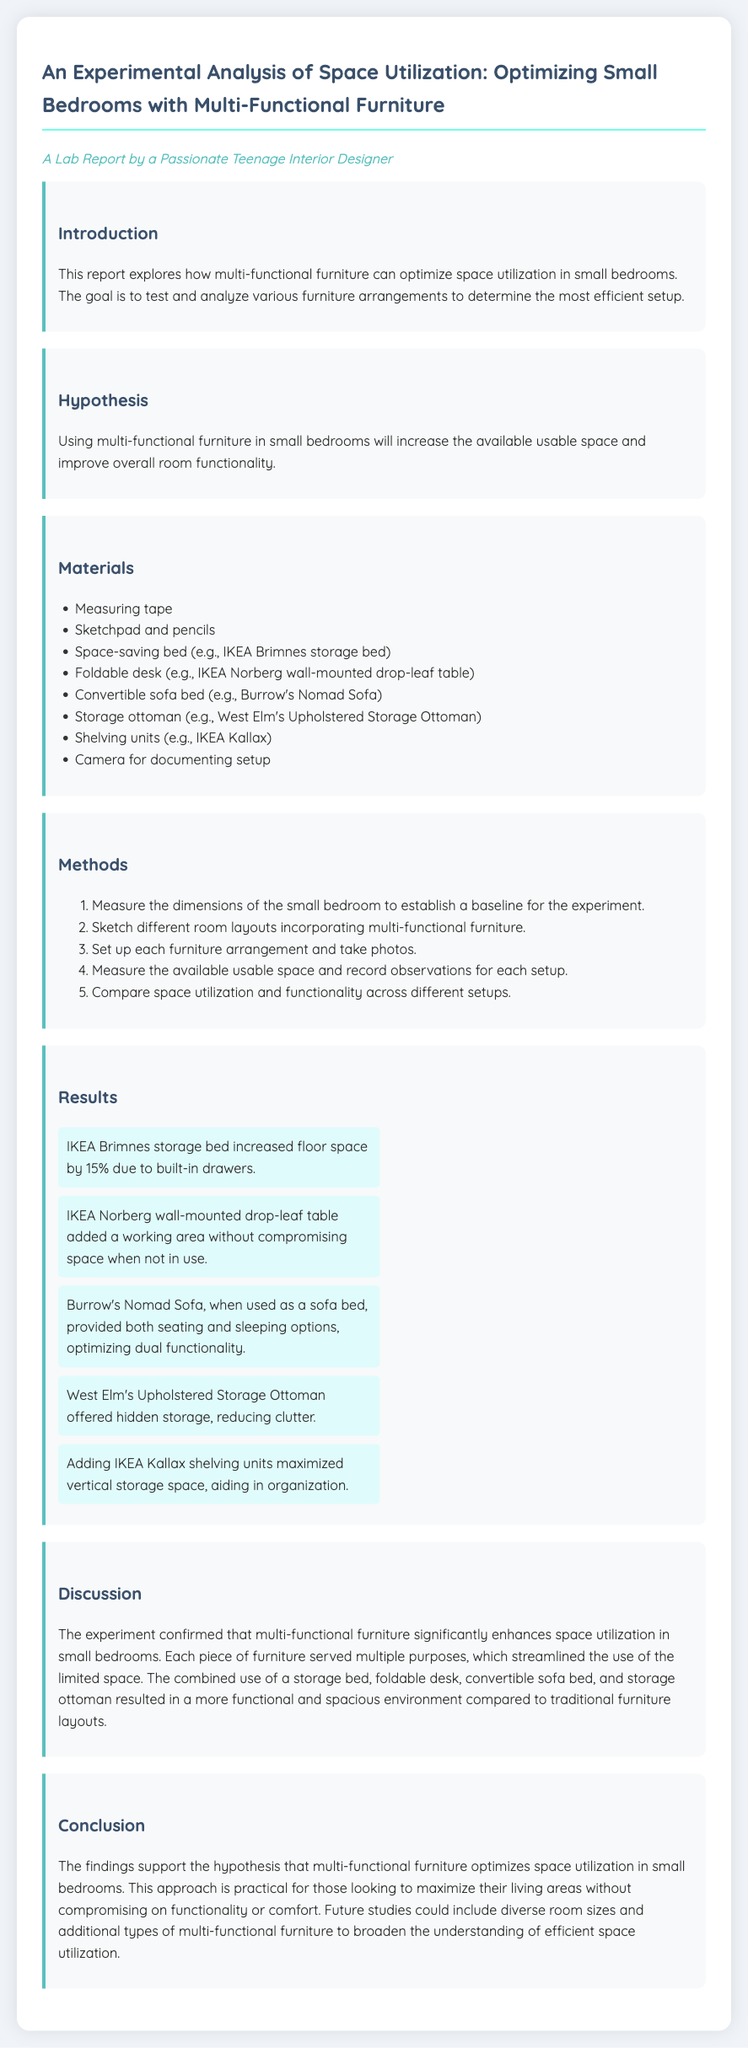what is the title of the lab report? The title of the lab report is specifically mentioned at the beginning of the document.
Answer: An Experimental Analysis of Space Utilization: Optimizing Small Bedrooms with Multi-Functional Furniture what is the hypothesis stated in the report? The hypothesis can be found in the section titled "Hypothesis."
Answer: Using multi-functional furniture in small bedrooms will increase the available usable space and improve overall room functionality how many materials are listed in the report? The number of materials can be counted from the "Materials" section of the document.
Answer: Eight which multi-functional furniture provided a working area without compromising space? This information is provided in the "Results" section where specific furniture functions are described.
Answer: IKEA Norberg wall-mounted drop-leaf table what percentage of floor space did the IKEA Brimnes storage bed increase? The percentage mentioned in the "Results" section indicates the impact on floor space by this furniture.
Answer: 15% what is one benefit of using a storage ottoman according to the results? The benefit is directly stated in the "Results" section discussing the advantages of the storage ottoman.
Answer: Hidden storage what conclusion is drawn about multi-functional furniture? The conclusion summarizes the overall findings and implications of the experiment.
Answer: Multi-functional furniture optimizes space utilization in small bedrooms what could future studies include to broaden the understanding of efficient space utilization? This is mentioned in the "Conclusion" section regarding the suggestions for further research.
Answer: Diverse room sizes and additional types of multi-functional furniture 